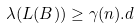<formula> <loc_0><loc_0><loc_500><loc_500>\lambda ( L ( B ) ) \geq \gamma ( n ) . d</formula> 